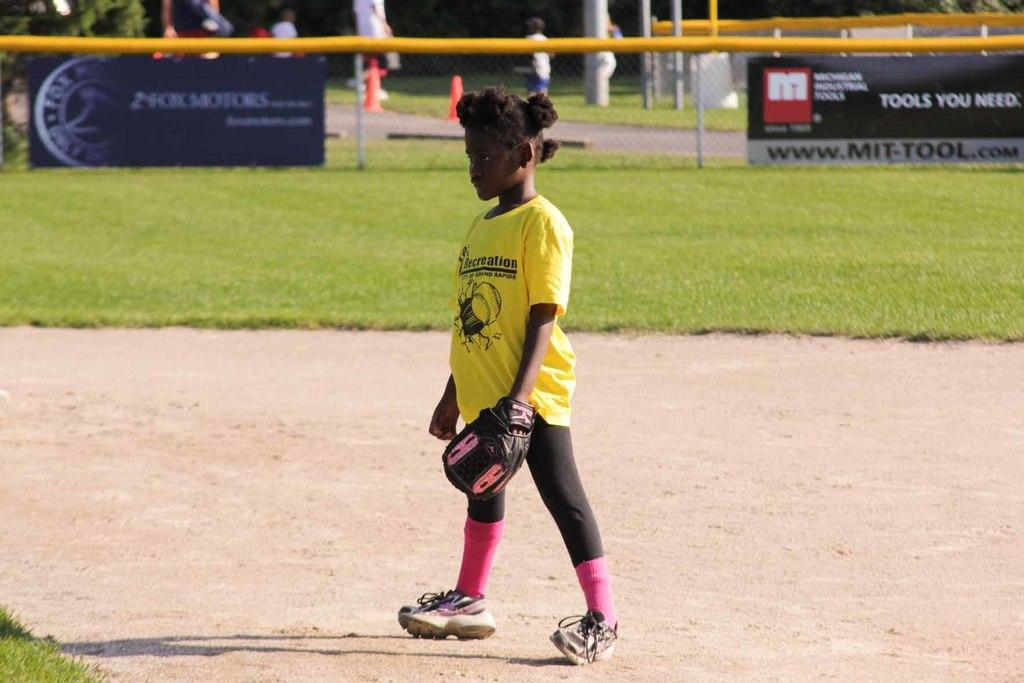What can be seen in the image? There is a child in the image. What is the child wearing on their feet and hands? The child is wearing shoes and gloves. Where is the child standing? The child is standing on the ground. What can be seen in the background of the image? There is grass, fences, banners, trees, and people in the background of the image. There are also objects in the background. What type of wheel is visible in the image? There is no wheel present in the image. Is the child experiencing a burn in the image? There is no indication of a burn in the image. 